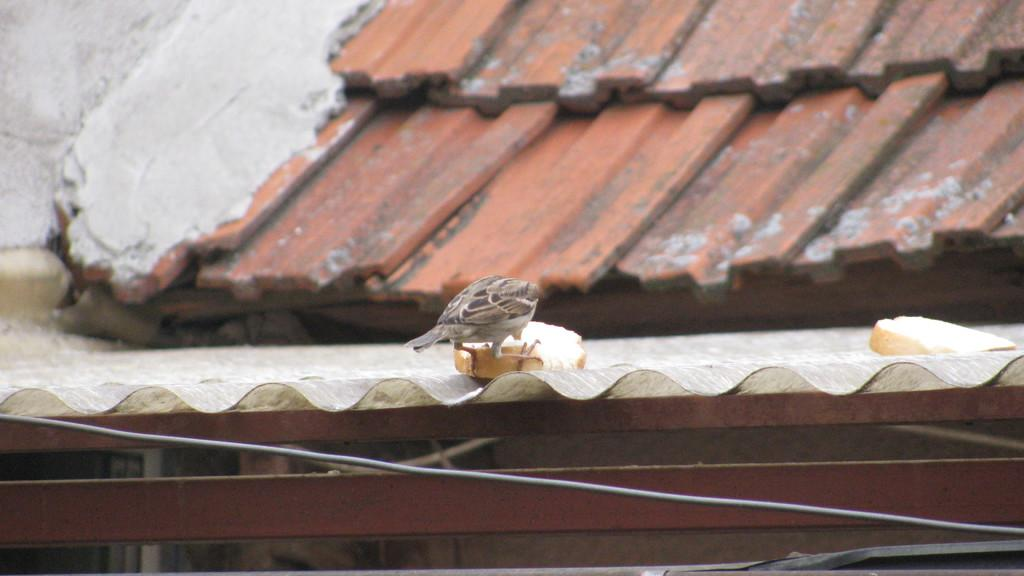What part of a building can be seen in the image? The image shows the roof of a building. What is the bird in the image doing? There is a bird sitting on a bread piece in the image. Where is the bread located in the image? There is a bread at the right side of the image. What else can be seen in the image besides the bird and bread? There is a cable in the image. What is the rate of the fire in the image? There is no fire present in the image, so it is not possible to determine a rate. 